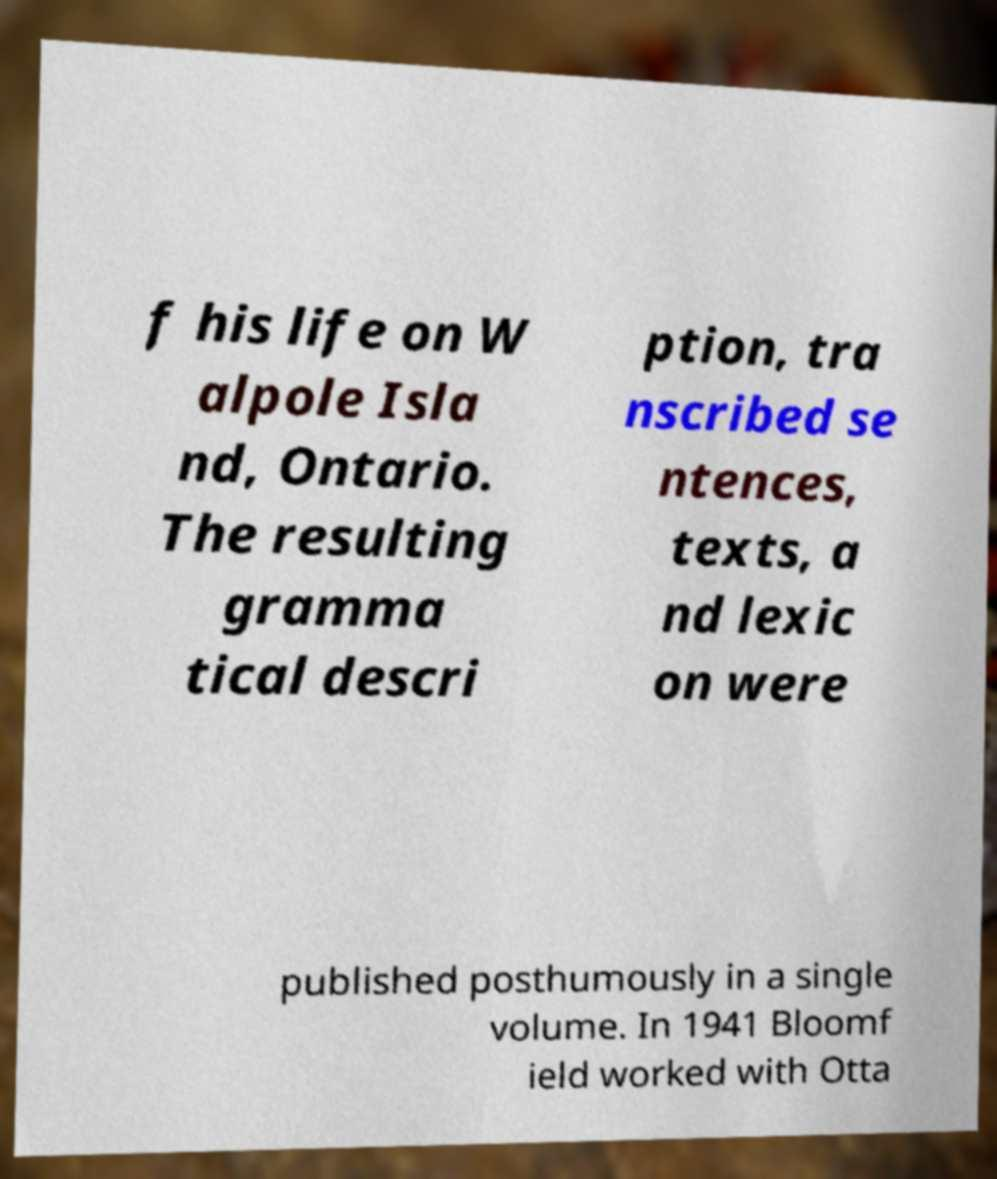Can you accurately transcribe the text from the provided image for me? f his life on W alpole Isla nd, Ontario. The resulting gramma tical descri ption, tra nscribed se ntences, texts, a nd lexic on were published posthumously in a single volume. In 1941 Bloomf ield worked with Otta 